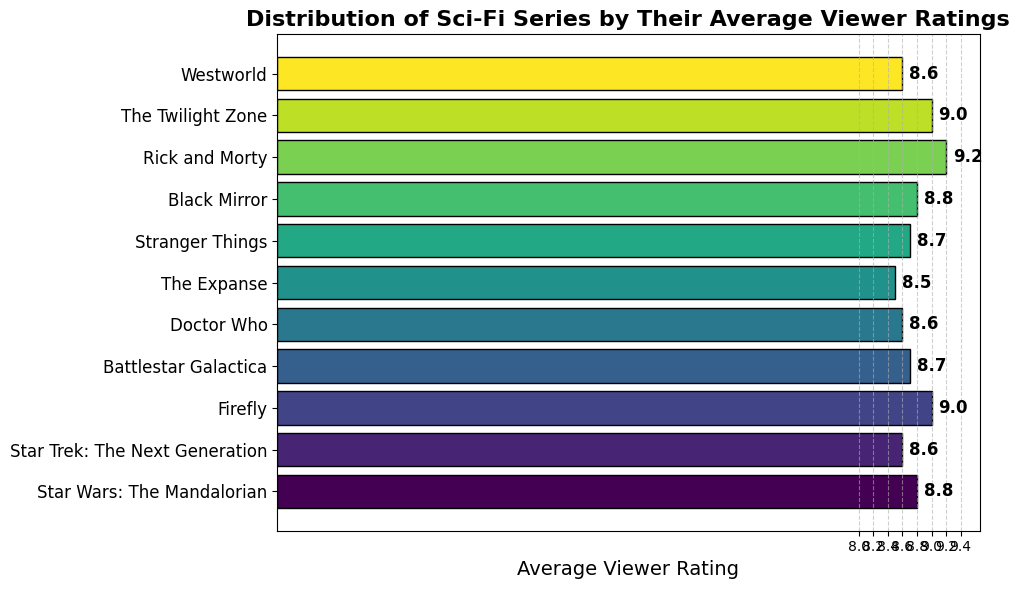Which series has the highest average viewer rating? The bar chart shows that "Rick and Morty" has the highest average viewer rating among all the series listed. The rating is shown at the end of the bar and labeled 9.2.
Answer: Rick and Morty What is the average rating of all the series presented? To determine the average rating, sum all the average ratings and divide by the number of series. The ratings are 8.8, 8.6, 9.0, 8.7, 8.6, 8.5, 8.7, 8.8, 9.2, 9.0, and 8.6. The sum is 96.5, and there are 11 series. The average is 96.5/11.
Answer: 8.77 Which series has the lowest average viewer rating? The bar chart indicates that "The Expanse" has the lowest average viewer rating among all the series listed. The rating is shown at the end of the bar and labeled 8.5.
Answer: The Expanse How many series have an average rating of 8.6? The bar chart shows that "Star Trek: The Next Generation," "Doctor Who," and "Westworld" each have an average rating of 8.6. Counting these series, we get a total of 3.
Answer: 3 What is the rating difference between "Firefly" and "Stranger Things"? The bar chart shows "Firefly" with a rating of 9.0 and "Stranger Things" with a rating of 8.7. The difference is calculated as 9.0 - 8.7.
Answer: 0.3 How many series have a rating higher than 8.8? The series "Rick and Morty" and "The Twilight Zone" have ratings higher than 8.8, specifically 9.2 and 9.0, respectively. Counting these series, we get a total of 2.
Answer: 2 Which two series have the same average viewer rating of 8.8? The bar chart shows that "Star Wars: The Mandalorian" and "Black Mirror" both have an average viewer rating of 8.8, denoted on their respective bars.
Answer: Star Wars: The Mandalorian and Black Mirror What is the combined rating of "Doctor Who" and "Battlestar Galactica"? The bar chart shows "Doctor Who" with a rating of 8.6 and "Battlestar Galactica" with a rating of 8.7. The combined rating is calculated as 8.6 + 8.7.
Answer: 17.3 Arrange the series with an 8.7 rating in alphabetical order. The series with an 8.7 rating are "Battlestar Galactica" and "Stranger Things." Arranging them alphabetically, we get: "Battlestar Galactica" then "Stranger Things."
Answer: Battlestar Galactica, Stranger Things 